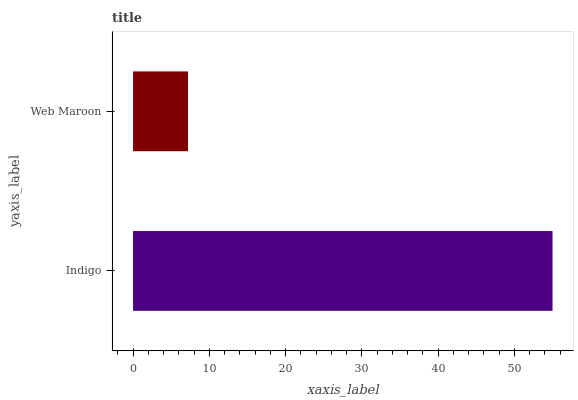Is Web Maroon the minimum?
Answer yes or no. Yes. Is Indigo the maximum?
Answer yes or no. Yes. Is Web Maroon the maximum?
Answer yes or no. No. Is Indigo greater than Web Maroon?
Answer yes or no. Yes. Is Web Maroon less than Indigo?
Answer yes or no. Yes. Is Web Maroon greater than Indigo?
Answer yes or no. No. Is Indigo less than Web Maroon?
Answer yes or no. No. Is Indigo the high median?
Answer yes or no. Yes. Is Web Maroon the low median?
Answer yes or no. Yes. Is Web Maroon the high median?
Answer yes or no. No. Is Indigo the low median?
Answer yes or no. No. 